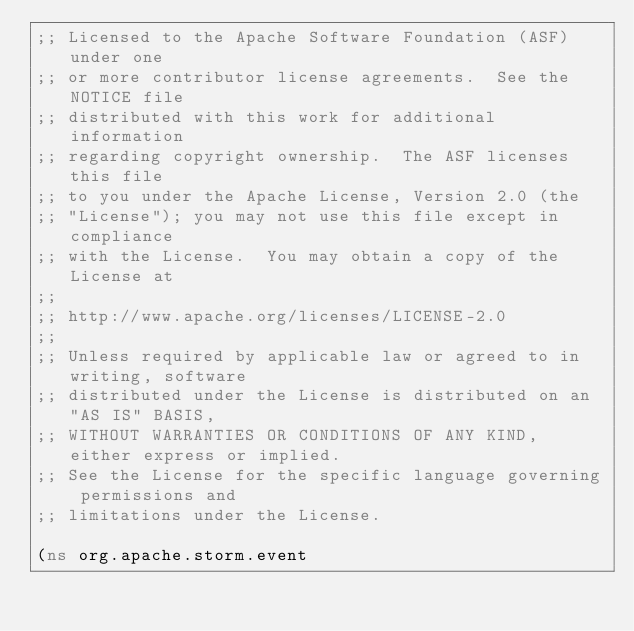Convert code to text. <code><loc_0><loc_0><loc_500><loc_500><_Clojure_>;; Licensed to the Apache Software Foundation (ASF) under one
;; or more contributor license agreements.  See the NOTICE file
;; distributed with this work for additional information
;; regarding copyright ownership.  The ASF licenses this file
;; to you under the Apache License, Version 2.0 (the
;; "License"); you may not use this file except in compliance
;; with the License.  You may obtain a copy of the License at
;;
;; http://www.apache.org/licenses/LICENSE-2.0
;;
;; Unless required by applicable law or agreed to in writing, software
;; distributed under the License is distributed on an "AS IS" BASIS,
;; WITHOUT WARRANTIES OR CONDITIONS OF ANY KIND, either express or implied.
;; See the License for the specific language governing permissions and
;; limitations under the License.

(ns org.apache.storm.event</code> 